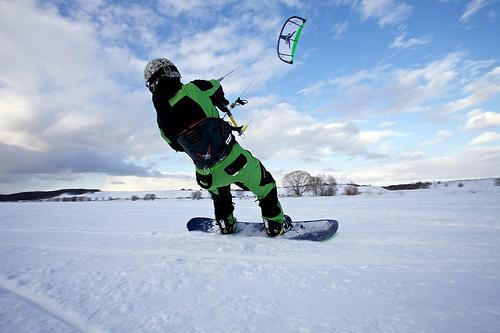Question: what color is the sky?
Choices:
A. Gray.
B. Orange.
C. Magenta.
D. Blue.
Answer with the letter. Answer: D Question: who took the picture?
Choices:
A. A friend.
B. A kid.
C. A girl.
D. A boy.
Answer with the letter. Answer: A Question: what color are the clouds?
Choices:
A. White.
B. Cream.
C. Grey.
D. Dark gray.
Answer with the letter. Answer: C Question: what color is the man's jacket?
Choices:
A. Blue.
B. Green.
C. Black.
D. Orange.
Answer with the letter. Answer: B 